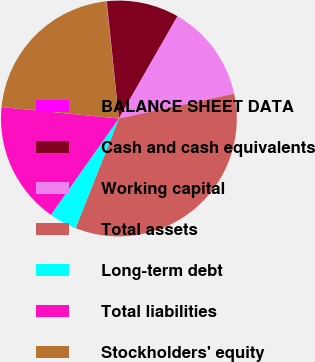<chart> <loc_0><loc_0><loc_500><loc_500><pie_chart><fcel>BALANCE SHEET DATA<fcel>Cash and cash equivalents<fcel>Working capital<fcel>Total assets<fcel>Long-term debt<fcel>Total liabilities<fcel>Stockholders' equity<nl><fcel>0.07%<fcel>9.91%<fcel>13.34%<fcel>34.36%<fcel>3.79%<fcel>16.77%<fcel>21.76%<nl></chart> 